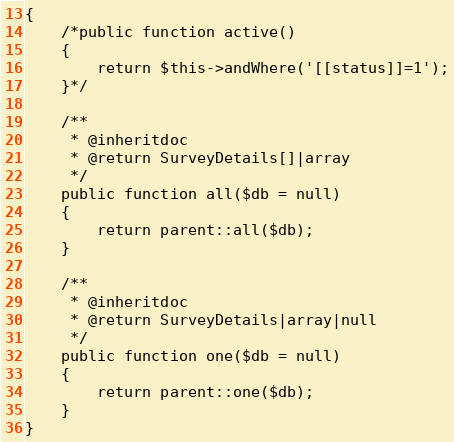Convert code to text. <code><loc_0><loc_0><loc_500><loc_500><_PHP_>{
    /*public function active()
    {
        return $this->andWhere('[[status]]=1');
    }*/

    /**
     * @inheritdoc
     * @return SurveyDetails[]|array
     */
    public function all($db = null)
    {
        return parent::all($db);
    }

    /**
     * @inheritdoc
     * @return SurveyDetails|array|null
     */
    public function one($db = null)
    {
        return parent::one($db);
    }
}
</code> 